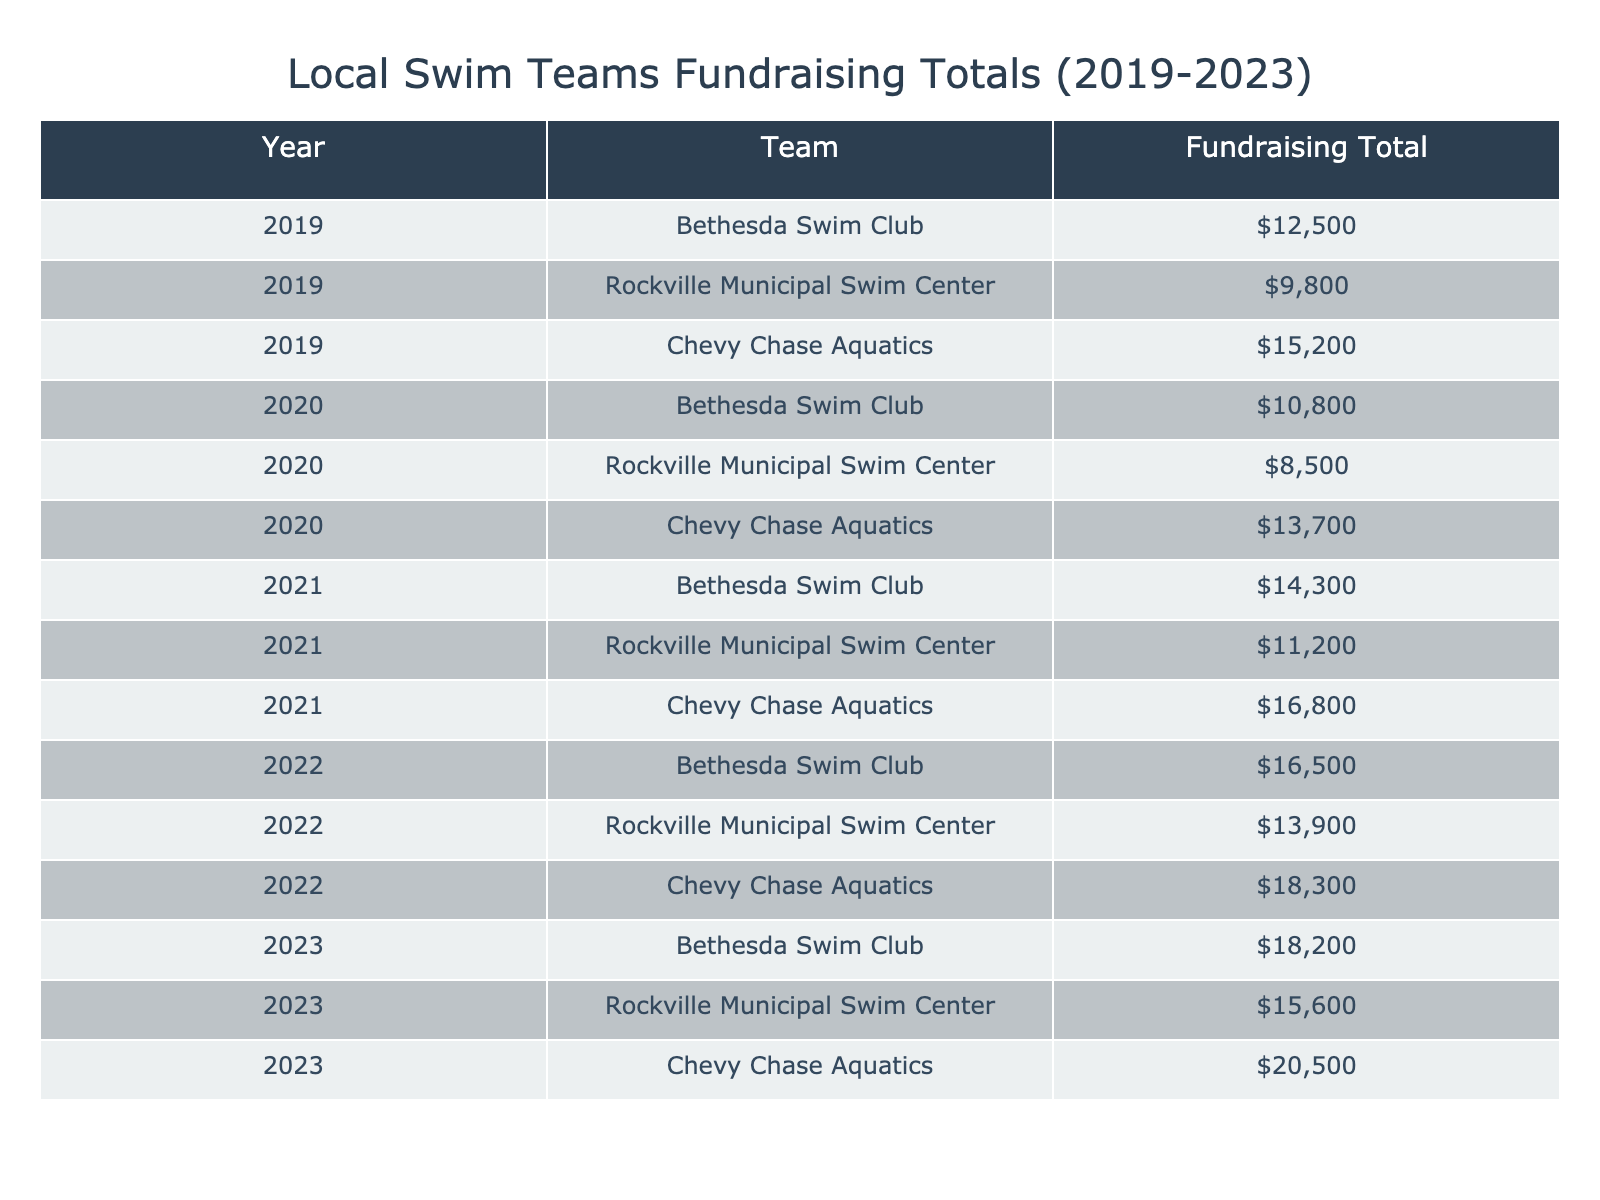What was the total fundraising amount for Bethesda Swim Club in 2021? In 2021, the table shows that the fundraising total for Bethesda Swim Club is $14,300.
Answer: $14,300 Which swim team had the highest fundraising total in 2023? The table indicates that Chevy Chase Aquatics had the highest fundraising total in 2023 with $20,500.
Answer: Chevy Chase Aquatics What is the average fundraising total for Rockville Municipal Swim Center over the five years? Adding the totals for Rockville Municipal Swim Center from the table gives $9,800 + $8,500 + $11,200 + $13,900 + $15,600 = $59,000. There are 5 years, so the average is $59,000 / 5 = $11,800.
Answer: $11,800 Was there an increase in fundraising for Chevy Chase Aquatics from 2019 to 2020? Comparing the totals, Chevy Chase Aquatics raised $15,200 in 2019 and $13,700 in 2020, which shows a decrease of $1,500.
Answer: No What is the total amount raised by all teams combined in 2022? Summing the amounts from the table for 2022: Bethesda Swim Club ($16,500) + Rockville Municipal Swim Center ($13,900) + Chevy Chase Aquatics ($18,300) equals $48,700.
Answer: $48,700 In which year did the Bethesda Swim Club experience the largest increase in fundraising compared to the previous year? The increases from year to year are as follows: from 2019 to 2020 it decreased by $1,700, from 2020 to 2021 it increased by $3,500, from 2021 to 2022 it increased by $2,200, and from 2022 to 2023 it increased by $1,700. The largest increase was from 2020 to 2021, which was $3,500.
Answer: 2021 Which team had the lowest fundraising total across all five years? From examining the table, Rockville Municipal Swim Center had the lowest total in 2019 at $9,800.
Answer: Rockville Municipal Swim Center in 2019 What is the total fundraising amount for Chevy Chase Aquatics from 2019 to 2023? Adding the totals for Chevy Chase Aquatics: $15,200 (2019) + $13,700 (2020) + $16,800 (2021) + $18,300 (2022) + $20,500 (2023) totals to $84,500.
Answer: $84,500 Was Rockville Municipal Swim Center’s fundraising ever below $10,000 in any year? Reviewing the table, Rockville Municipal Swim Center had below $10,000 in 2019 ($9,800) and also in 2020 ($8,500). This confirms it was below $10,000 in those years.
Answer: Yes 